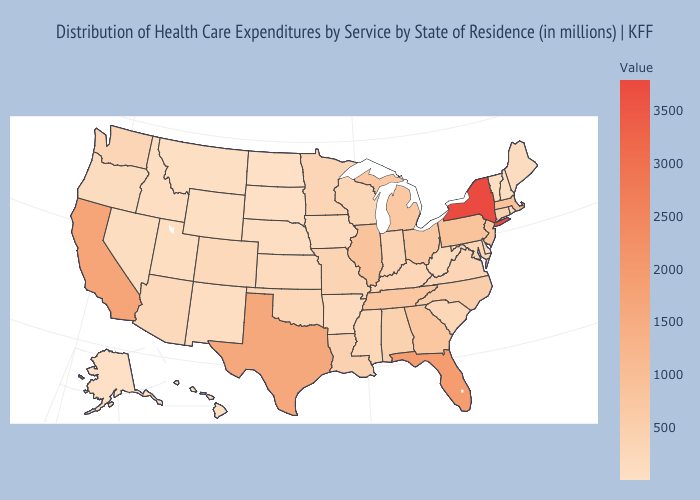Does California have a lower value than Vermont?
Write a very short answer. No. Does New Jersey have the highest value in the USA?
Short answer required. No. Does Florida have the highest value in the South?
Answer briefly. Yes. Among the states that border North Dakota , does South Dakota have the lowest value?
Concise answer only. Yes. 